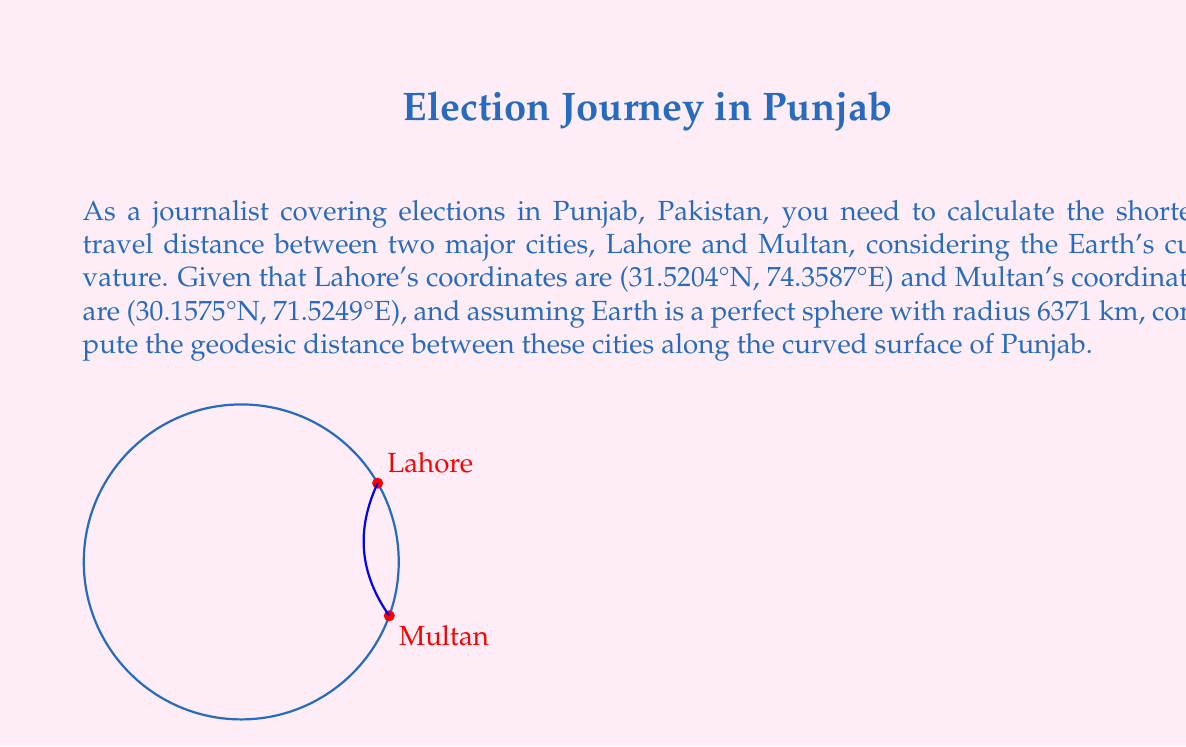Teach me how to tackle this problem. To solve this problem, we'll use the Haversine formula, which calculates the great-circle distance between two points on a sphere given their longitudes and latitudes. Here's the step-by-step solution:

1) Convert the coordinates from degrees to radians:
   Lahore: $\phi_1 = 31.5204° \times \frac{\pi}{180} = 0.5502$ rad, $\lambda_1 = 74.3587° \times \frac{\pi}{180} = 1.2978$ rad
   Multan: $\phi_2 = 30.1575° \times \frac{\pi}{180} = 0.5264$ rad, $\lambda_2 = 71.5249° \times \frac{\pi}{180} = 1.2479$ rad

2) Calculate the differences:
   $\Delta\phi = \phi_2 - \phi_1 = -0.0238$ rad
   $\Delta\lambda = \lambda_2 - \lambda_1 = -0.0499$ rad

3) Apply the Haversine formula:
   $$a = \sin^2(\frac{\Delta\phi}{2}) + \cos(\phi_1) \cos(\phi_2) \sin^2(\frac{\Delta\lambda}{2})$$
   $$c = 2 \times \arctan2(\sqrt{a}, \sqrt{1-a})$$

4) Substitute the values:
   $$a = \sin^2(-0.0119) + \cos(0.5502) \cos(0.5264) \sin^2(-0.02495)$$
   $$a = 0.0002842$$
   $$c = 2 \times \arctan2(\sqrt{0.0002842}, \sqrt{1-0.0002842}) = 0.03371$$

5) Calculate the distance:
   $$d = R \times c$$
   where $R$ is the Earth's radius (6371 km)
   $$d = 6371 \times 0.03371 = 214.77 \text{ km}$$

Thus, the geodesic distance between Lahore and Multan along the curved surface of Punjab is approximately 214.77 km.
Answer: 214.77 km 